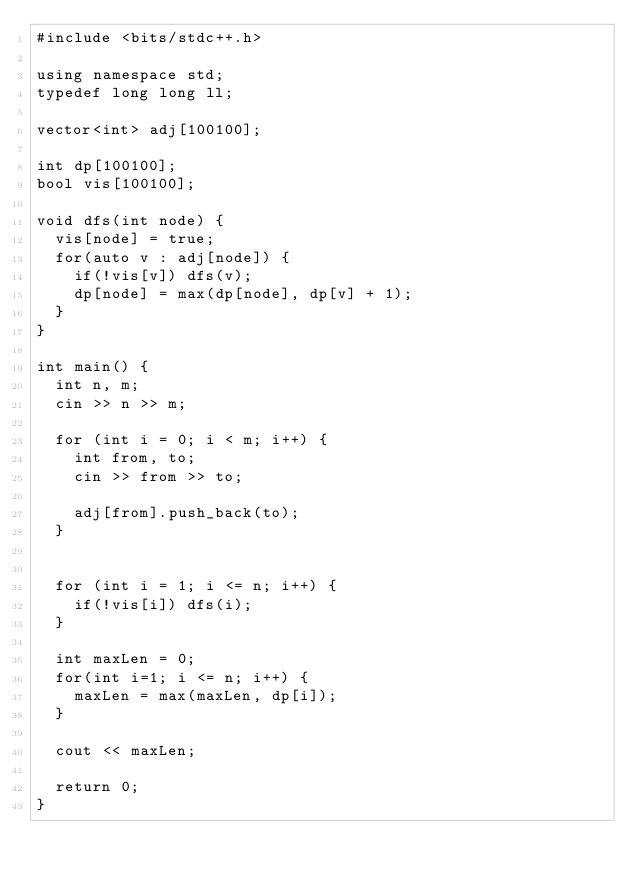<code> <loc_0><loc_0><loc_500><loc_500><_C++_>#include <bits/stdc++.h>

using namespace std;
typedef long long ll;

vector<int> adj[100100];

int dp[100100];
bool vis[100100];

void dfs(int node) {
	vis[node] = true;
	for(auto v : adj[node]) {
		if(!vis[v]) dfs(v);
		dp[node] = max(dp[node], dp[v] + 1);
	}
}

int main() {
	int n, m;
	cin >> n >> m;

	for (int i = 0; i < m; i++) {
		int from, to;
		cin >> from >> to;

		adj[from].push_back(to);
	}

	
	for (int i = 1; i <= n; i++) {
		if(!vis[i]) dfs(i);
	}
	
	int maxLen = 0;
	for(int i=1; i <= n; i++) {
		maxLen = max(maxLen, dp[i]);
	}

	cout << maxLen;

	return 0;
}</code> 